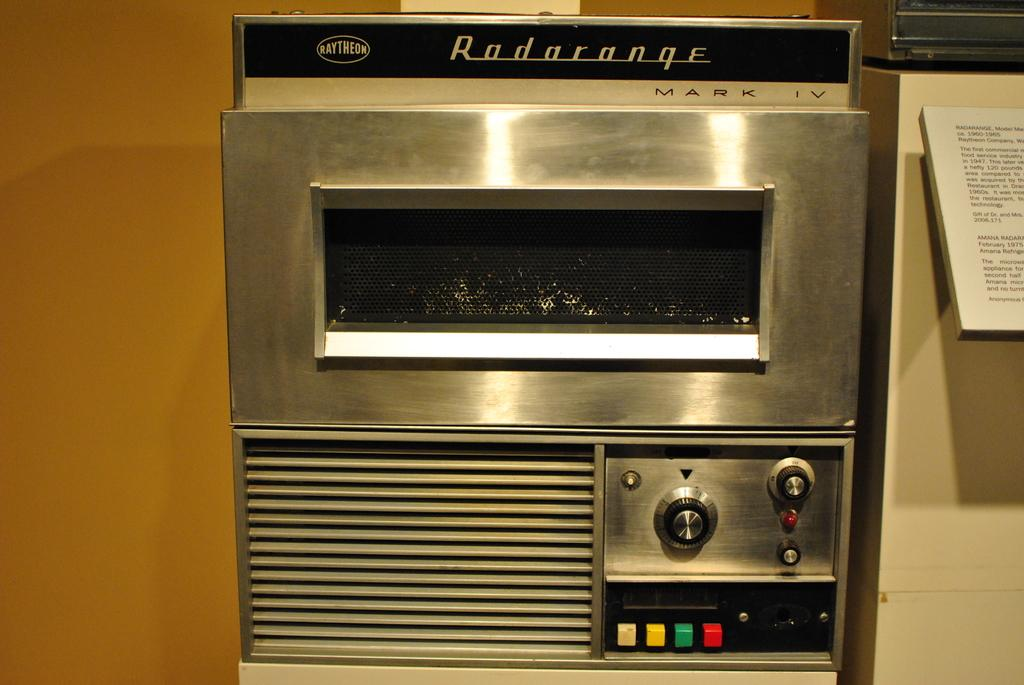Provide a one-sentence caption for the provided image. Silver oven named Radarange that has many buttons. 